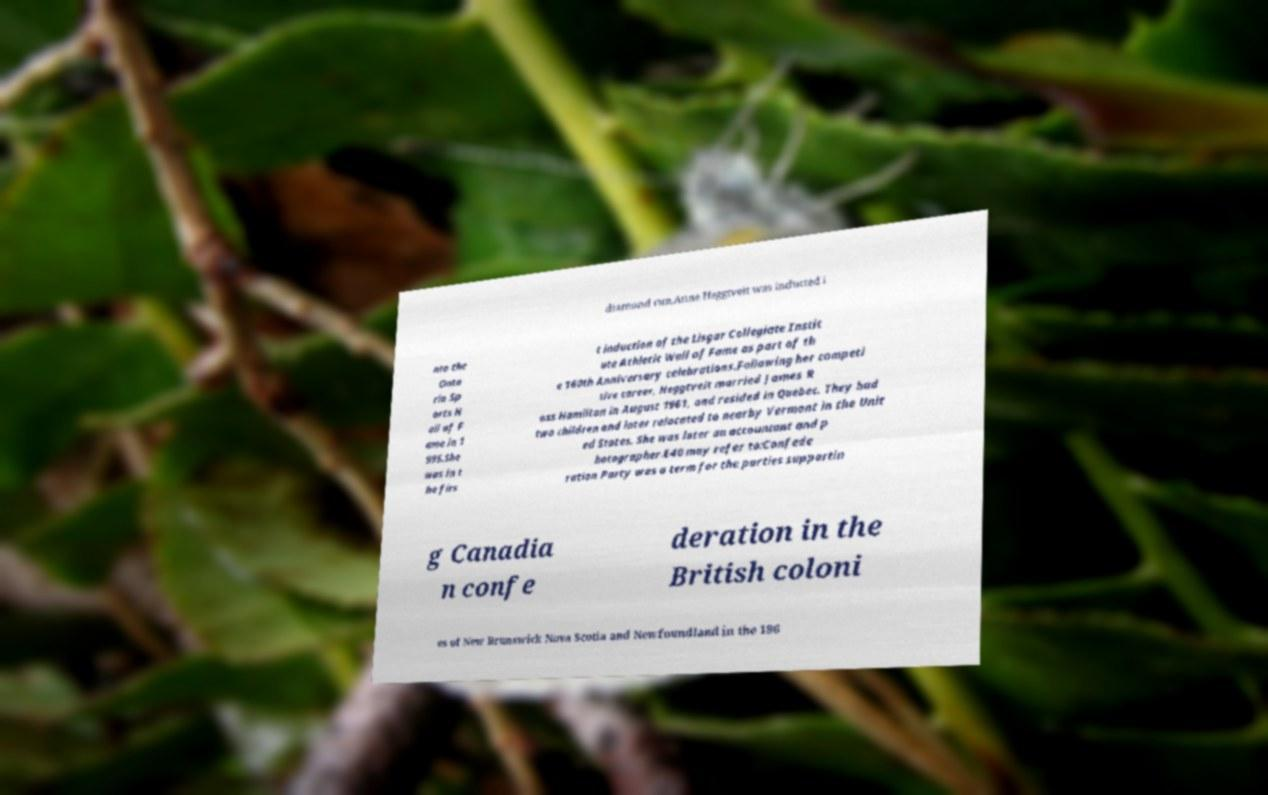For documentation purposes, I need the text within this image transcribed. Could you provide that? diamond run.Anne Heggtveit was inducted i nto the Onta rio Sp orts H all of F ame in 1 995.She was in t he firs t induction of the Lisgar Collegiate Instit ute Athletic Wall of Fame as part of th e 160th Anniversary celebrations.Following her competi tive career, Heggtveit married James R oss Hamilton in August 1961, and resided in Quebec. They had two children and later relocated to nearby Vermont in the Unit ed States. She was later an accountant and p hotographer.E40 may refer to:Confede ration Party was a term for the parties supportin g Canadia n confe deration in the British coloni es of New Brunswick Nova Scotia and Newfoundland in the 186 